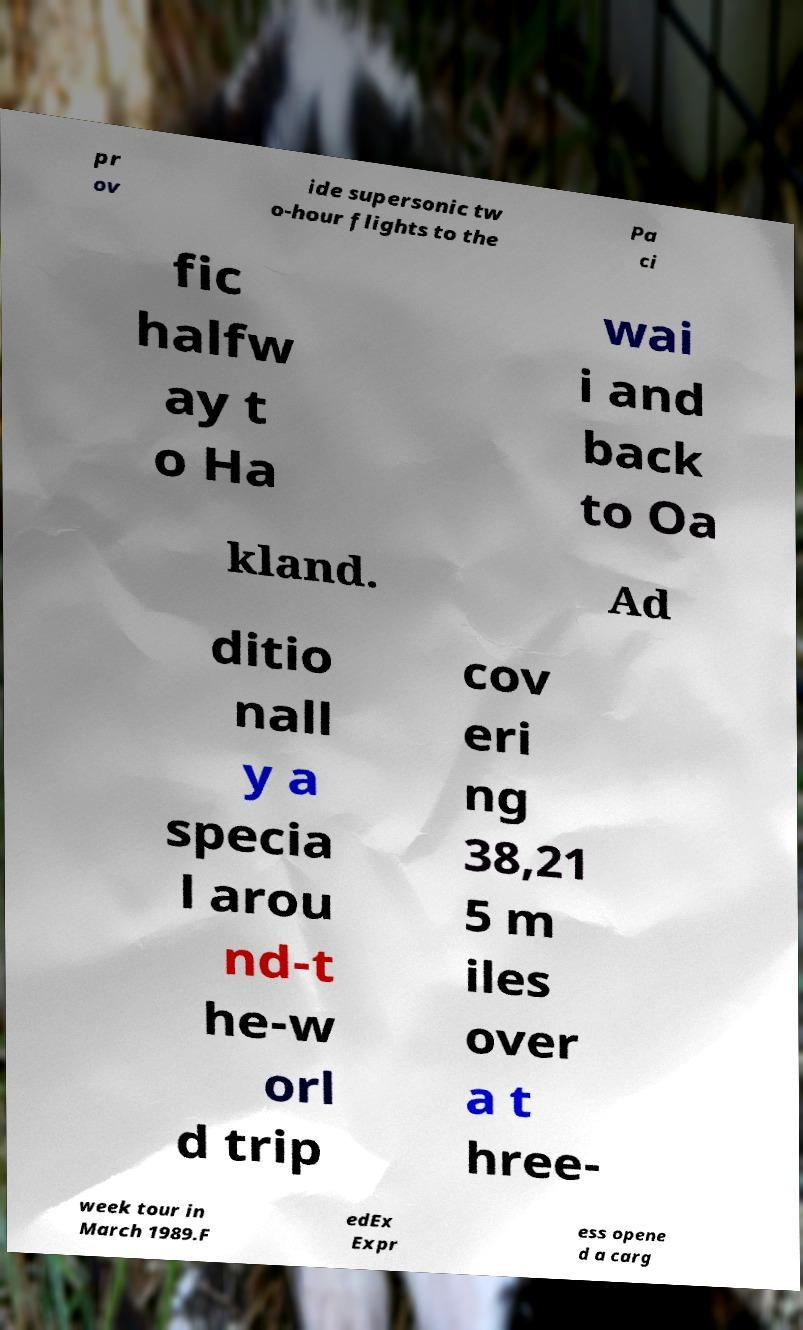For documentation purposes, I need the text within this image transcribed. Could you provide that? pr ov ide supersonic tw o-hour flights to the Pa ci fic halfw ay t o Ha wai i and back to Oa kland. Ad ditio nall y a specia l arou nd-t he-w orl d trip cov eri ng 38,21 5 m iles over a t hree- week tour in March 1989.F edEx Expr ess opene d a carg 